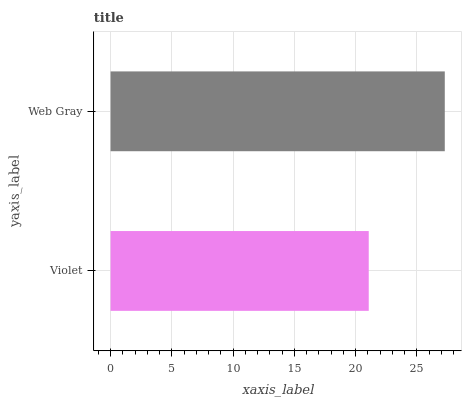Is Violet the minimum?
Answer yes or no. Yes. Is Web Gray the maximum?
Answer yes or no. Yes. Is Web Gray the minimum?
Answer yes or no. No. Is Web Gray greater than Violet?
Answer yes or no. Yes. Is Violet less than Web Gray?
Answer yes or no. Yes. Is Violet greater than Web Gray?
Answer yes or no. No. Is Web Gray less than Violet?
Answer yes or no. No. Is Web Gray the high median?
Answer yes or no. Yes. Is Violet the low median?
Answer yes or no. Yes. Is Violet the high median?
Answer yes or no. No. Is Web Gray the low median?
Answer yes or no. No. 